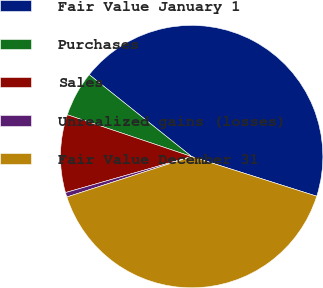Convert chart to OTSL. <chart><loc_0><loc_0><loc_500><loc_500><pie_chart><fcel>Fair Value January 1<fcel>Purchases<fcel>Sales<fcel>Unrealized gains (losses)<fcel>Fair Value December 31<nl><fcel>44.15%<fcel>5.57%<fcel>9.59%<fcel>0.56%<fcel>40.13%<nl></chart> 